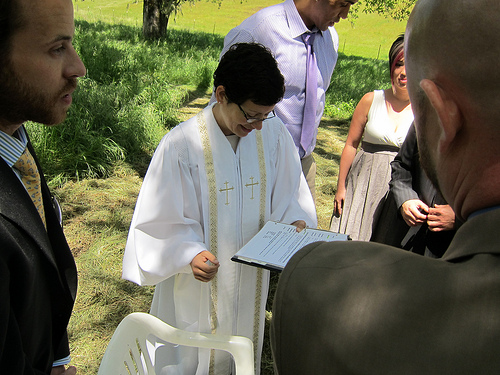<image>
Is the woman on the book? No. The woman is not positioned on the book. They may be near each other, but the woman is not supported by or resting on top of the book. 